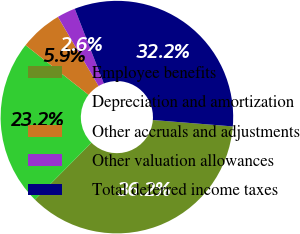Convert chart to OTSL. <chart><loc_0><loc_0><loc_500><loc_500><pie_chart><fcel>Employee benefits<fcel>Depreciation and amortization<fcel>Other accruals and adjustments<fcel>Other valuation allowances<fcel>Total deferred income taxes<nl><fcel>36.18%<fcel>23.16%<fcel>5.92%<fcel>2.56%<fcel>32.18%<nl></chart> 